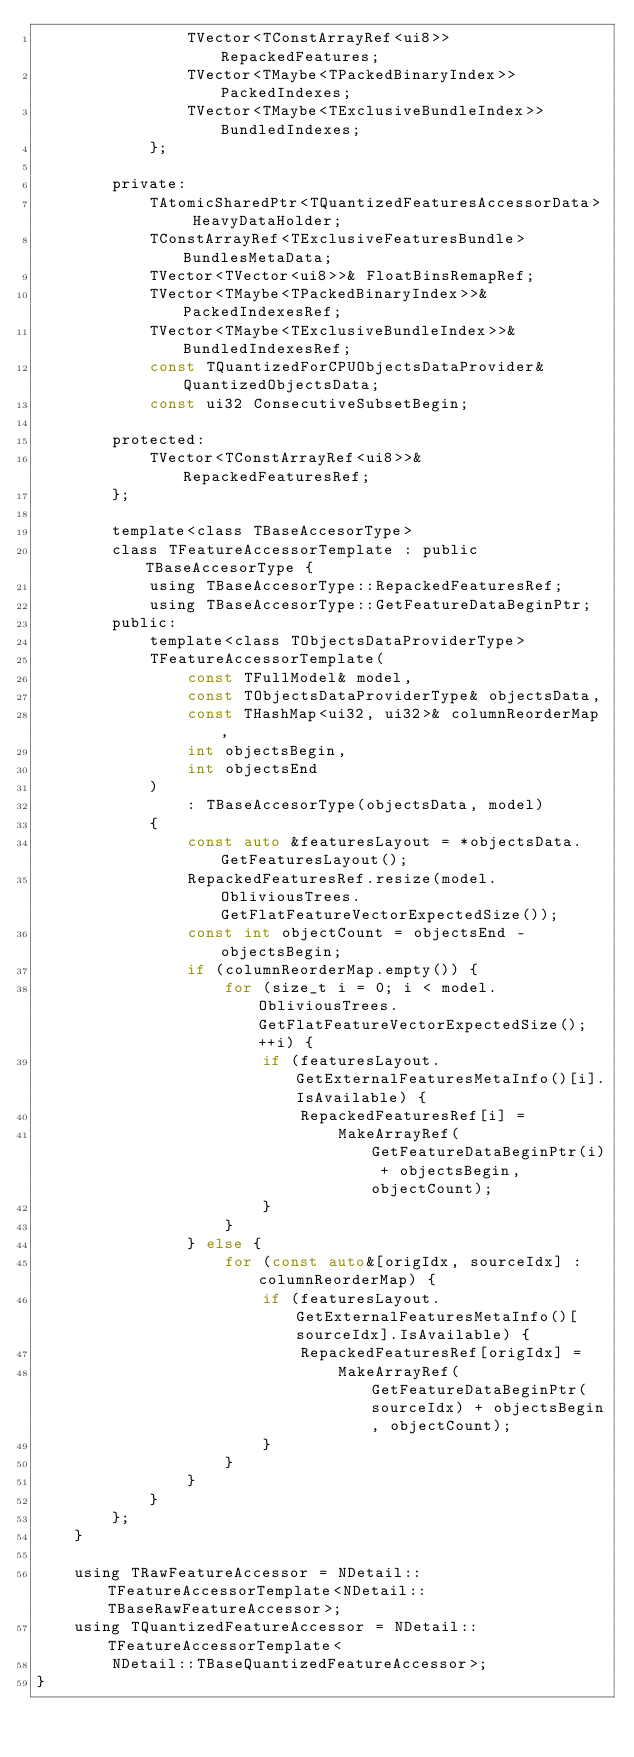Convert code to text. <code><loc_0><loc_0><loc_500><loc_500><_C_>                TVector<TConstArrayRef<ui8>> RepackedFeatures;
                TVector<TMaybe<TPackedBinaryIndex>> PackedIndexes;
                TVector<TMaybe<TExclusiveBundleIndex>> BundledIndexes;
            };

        private:
            TAtomicSharedPtr<TQuantizedFeaturesAccessorData> HeavyDataHolder;
            TConstArrayRef<TExclusiveFeaturesBundle> BundlesMetaData;
            TVector<TVector<ui8>>& FloatBinsRemapRef;
            TVector<TMaybe<TPackedBinaryIndex>>& PackedIndexesRef;
            TVector<TMaybe<TExclusiveBundleIndex>>& BundledIndexesRef;
            const TQuantizedForCPUObjectsDataProvider& QuantizedObjectsData;
            const ui32 ConsecutiveSubsetBegin;

        protected:
            TVector<TConstArrayRef<ui8>>& RepackedFeaturesRef;
        };

        template<class TBaseAccesorType>
        class TFeatureAccessorTemplate : public TBaseAccesorType {
            using TBaseAccesorType::RepackedFeaturesRef;
            using TBaseAccesorType::GetFeatureDataBeginPtr;
        public:
            template<class TObjectsDataProviderType>
            TFeatureAccessorTemplate(
                const TFullModel& model,
                const TObjectsDataProviderType& objectsData,
                const THashMap<ui32, ui32>& columnReorderMap,
                int objectsBegin,
                int objectsEnd
            )
                : TBaseAccesorType(objectsData, model)
            {
                const auto &featuresLayout = *objectsData.GetFeaturesLayout();
                RepackedFeaturesRef.resize(model.ObliviousTrees.GetFlatFeatureVectorExpectedSize());
                const int objectCount = objectsEnd - objectsBegin;
                if (columnReorderMap.empty()) {
                    for (size_t i = 0; i < model.ObliviousTrees.GetFlatFeatureVectorExpectedSize(); ++i) {
                        if (featuresLayout.GetExternalFeaturesMetaInfo()[i].IsAvailable) {
                            RepackedFeaturesRef[i] =
                                MakeArrayRef(GetFeatureDataBeginPtr(i) + objectsBegin, objectCount);
                        }
                    }
                } else {
                    for (const auto&[origIdx, sourceIdx] : columnReorderMap) {
                        if (featuresLayout.GetExternalFeaturesMetaInfo()[sourceIdx].IsAvailable) {
                            RepackedFeaturesRef[origIdx] =
                                MakeArrayRef(GetFeatureDataBeginPtr(sourceIdx) + objectsBegin, objectCount);
                        }
                    }
                }
            }
        };
    }

    using TRawFeatureAccessor = NDetail::TFeatureAccessorTemplate<NDetail::TBaseRawFeatureAccessor>;
    using TQuantizedFeatureAccessor = NDetail::TFeatureAccessorTemplate<
        NDetail::TBaseQuantizedFeatureAccessor>;
}
</code> 